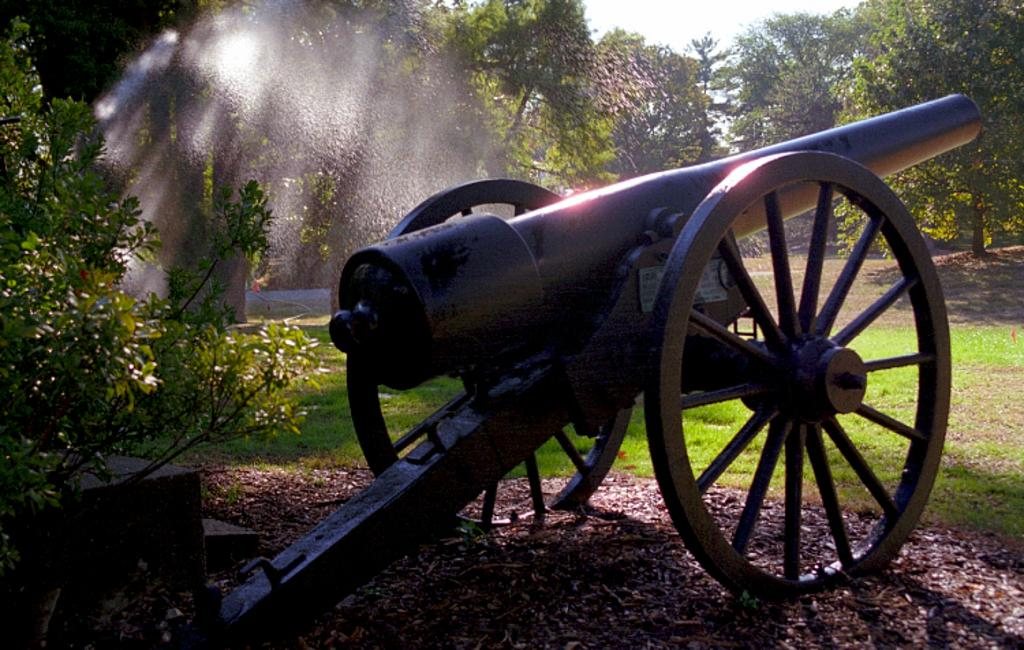What is the main object in the picture? There is a canon in the picture. What can be seen in the background of the picture? Trees are visible in the background of the picture. How would you describe the sky in the picture? The sky appears to be cloudy in the picture. What type of terrain is present in the picture? Grass is present on the ground in the picture. What type of ray is visible in the picture? There is no ray present in the picture; it features a canon, trees, a cloudy sky, and grass on the ground. What message of hope can be seen in the picture? There is no specific message of hope depicted in the picture; it is a scene with a canon, trees, a cloudy sky, and grass on the ground. 